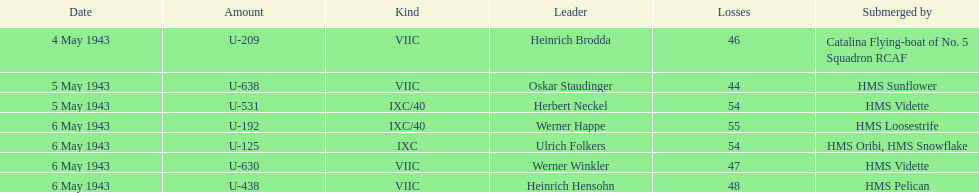Which u-boat had more than 54 casualties? U-192. 